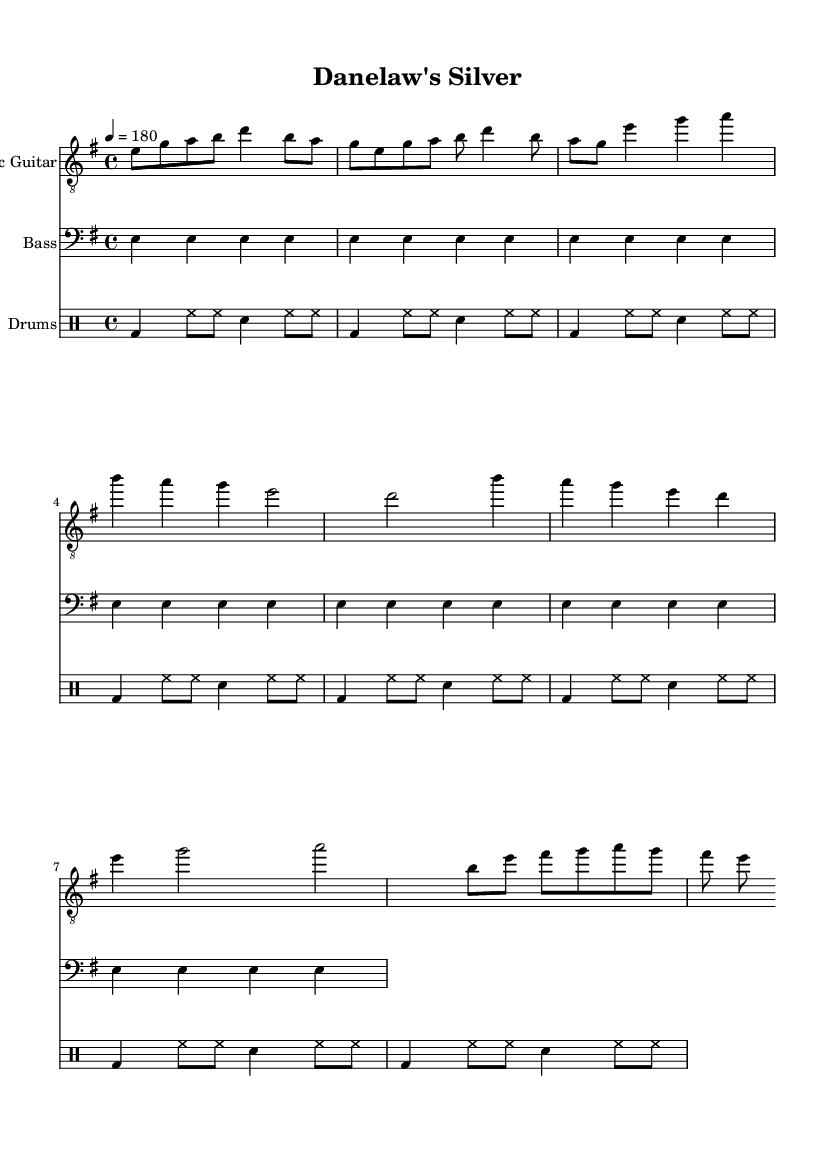What is the key signature of this music? The key signature is indicated at the beginning of the score and shows one sharp, which corresponds to E minor or G major. In this case, since E minor is specified in the global context, the key signature is E minor.
Answer: E minor What is the time signature of this music? The time signature is found at the beginning of the score, presenting a "4/4" indication which means there are four beats in each measure and the quarter note gets the beat.
Answer: 4/4 What is the tempo marking for this piece? The tempo marking is located in the global section of the music and shows "4 = 180," indicating that each quarter note is to be played at a tempo of 180 beats per minute.
Answer: 180 How many times is the main riff repeated? The main riff section is indicated in the electric guitar part, where it explicitly states to repeat the section 'unfold 2' which means it plays two times.
Answer: 2 What is the primary rhythm for the drum part? The drum part starts with a basic pattern shown in the drummode section, alternating between bass drum, hi-hat, and snare drum, typical for metal music, which is outlined and repeated four times.
Answer: Basic drum pattern In which section does the bridge appear in the music? The bridge section is identified in the electric guitar part and specifically labeled as "Bridge Riff," distinct from the main riff and verse sections; looking through the eyes of musical structure shows this context.
Answer: Bridge Riff What is the instrument identified as the "Bass" part? The bass part is highlighted in the score section under the label instrumentName = "Bass", which indicates that the instrument used in this part is a bass guitar, commonly found in heavy metal music for rhythm.
Answer: Bass guitar 